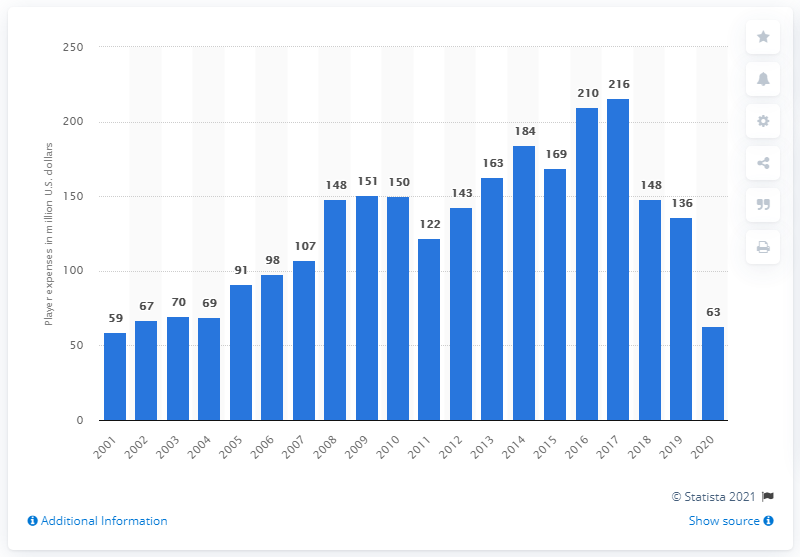Specify some key components in this picture. In 2020, the Detroit Tigers' payroll was approximately 63 million dollars. 